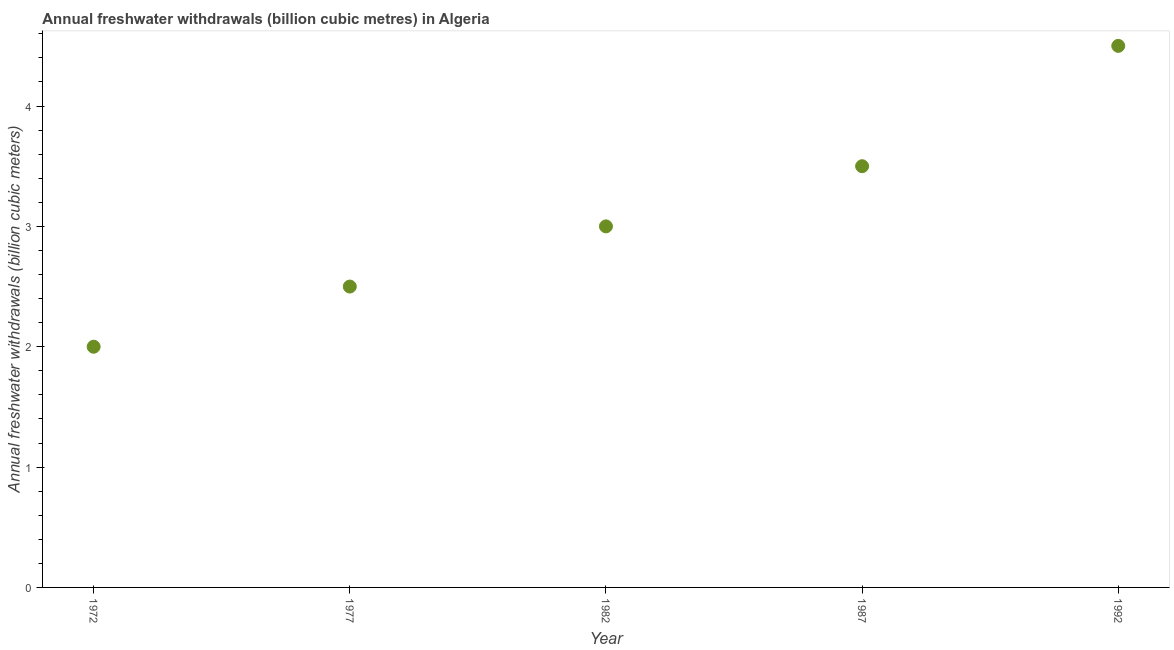What is the annual freshwater withdrawals in 1992?
Make the answer very short. 4.5. Across all years, what is the maximum annual freshwater withdrawals?
Offer a very short reply. 4.5. In which year was the annual freshwater withdrawals maximum?
Your answer should be very brief. 1992. What is the difference between the annual freshwater withdrawals in 1977 and 1982?
Your response must be concise. -0.5. What is the average annual freshwater withdrawals per year?
Your response must be concise. 3.1. What is the median annual freshwater withdrawals?
Your response must be concise. 3. In how many years, is the annual freshwater withdrawals greater than 1.6 billion cubic meters?
Offer a terse response. 5. Do a majority of the years between 1992 and 1977 (inclusive) have annual freshwater withdrawals greater than 2.6 billion cubic meters?
Give a very brief answer. Yes. What is the ratio of the annual freshwater withdrawals in 1972 to that in 1987?
Ensure brevity in your answer.  0.57. Is the annual freshwater withdrawals in 1972 less than that in 1977?
Your answer should be very brief. Yes. What is the difference between the highest and the lowest annual freshwater withdrawals?
Your answer should be very brief. 2.5. In how many years, is the annual freshwater withdrawals greater than the average annual freshwater withdrawals taken over all years?
Your answer should be very brief. 2. How many dotlines are there?
Your answer should be compact. 1. What is the title of the graph?
Make the answer very short. Annual freshwater withdrawals (billion cubic metres) in Algeria. What is the label or title of the Y-axis?
Offer a terse response. Annual freshwater withdrawals (billion cubic meters). What is the Annual freshwater withdrawals (billion cubic meters) in 1977?
Offer a very short reply. 2.5. What is the Annual freshwater withdrawals (billion cubic meters) in 1982?
Your answer should be very brief. 3. What is the Annual freshwater withdrawals (billion cubic meters) in 1992?
Offer a terse response. 4.5. What is the difference between the Annual freshwater withdrawals (billion cubic meters) in 1972 and 1982?
Your response must be concise. -1. What is the difference between the Annual freshwater withdrawals (billion cubic meters) in 1972 and 1992?
Provide a succinct answer. -2.5. What is the difference between the Annual freshwater withdrawals (billion cubic meters) in 1977 and 1982?
Offer a terse response. -0.5. What is the difference between the Annual freshwater withdrawals (billion cubic meters) in 1982 and 1992?
Ensure brevity in your answer.  -1.5. What is the difference between the Annual freshwater withdrawals (billion cubic meters) in 1987 and 1992?
Offer a very short reply. -1. What is the ratio of the Annual freshwater withdrawals (billion cubic meters) in 1972 to that in 1977?
Your response must be concise. 0.8. What is the ratio of the Annual freshwater withdrawals (billion cubic meters) in 1972 to that in 1982?
Your answer should be compact. 0.67. What is the ratio of the Annual freshwater withdrawals (billion cubic meters) in 1972 to that in 1987?
Give a very brief answer. 0.57. What is the ratio of the Annual freshwater withdrawals (billion cubic meters) in 1972 to that in 1992?
Keep it short and to the point. 0.44. What is the ratio of the Annual freshwater withdrawals (billion cubic meters) in 1977 to that in 1982?
Your response must be concise. 0.83. What is the ratio of the Annual freshwater withdrawals (billion cubic meters) in 1977 to that in 1987?
Provide a short and direct response. 0.71. What is the ratio of the Annual freshwater withdrawals (billion cubic meters) in 1977 to that in 1992?
Provide a short and direct response. 0.56. What is the ratio of the Annual freshwater withdrawals (billion cubic meters) in 1982 to that in 1987?
Your response must be concise. 0.86. What is the ratio of the Annual freshwater withdrawals (billion cubic meters) in 1982 to that in 1992?
Keep it short and to the point. 0.67. What is the ratio of the Annual freshwater withdrawals (billion cubic meters) in 1987 to that in 1992?
Provide a succinct answer. 0.78. 